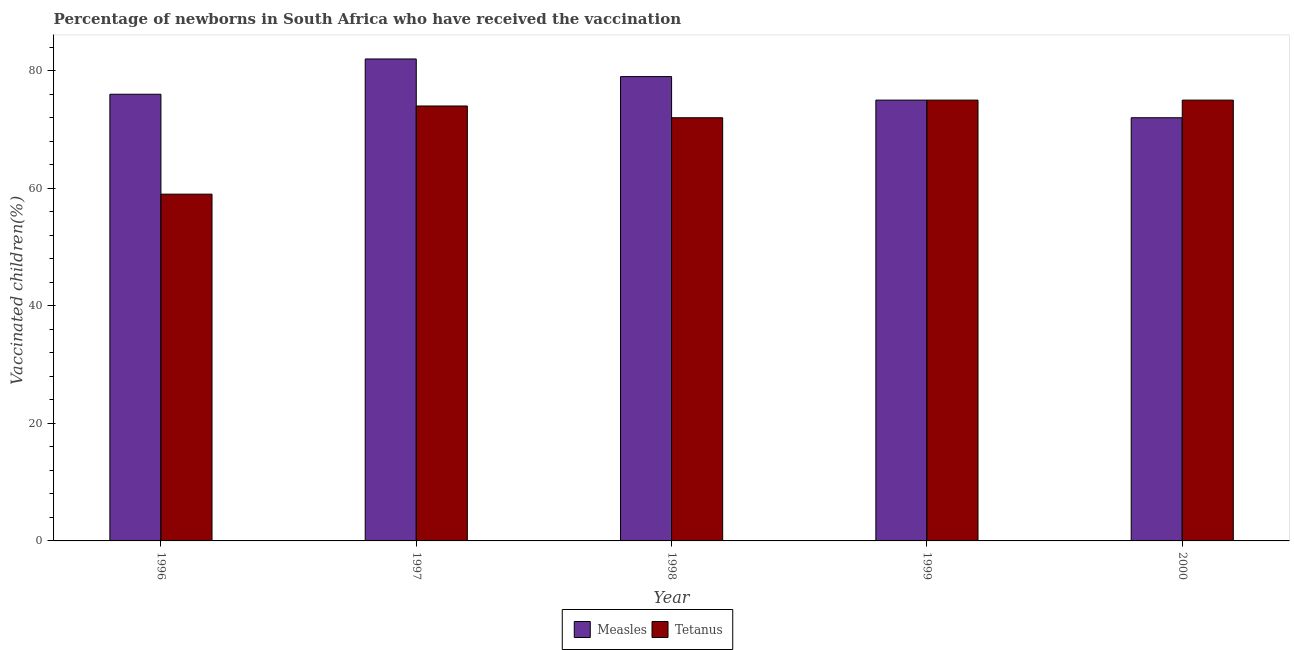How many groups of bars are there?
Provide a succinct answer. 5. Are the number of bars per tick equal to the number of legend labels?
Offer a terse response. Yes. How many bars are there on the 2nd tick from the left?
Ensure brevity in your answer.  2. How many bars are there on the 5th tick from the right?
Ensure brevity in your answer.  2. In how many cases, is the number of bars for a given year not equal to the number of legend labels?
Provide a succinct answer. 0. What is the percentage of newborns who received vaccination for measles in 2000?
Keep it short and to the point. 72. Across all years, what is the maximum percentage of newborns who received vaccination for tetanus?
Offer a very short reply. 75. Across all years, what is the minimum percentage of newborns who received vaccination for measles?
Your response must be concise. 72. What is the total percentage of newborns who received vaccination for tetanus in the graph?
Give a very brief answer. 355. What is the difference between the percentage of newborns who received vaccination for tetanus in 1996 and that in 2000?
Your answer should be compact. -16. What is the difference between the percentage of newborns who received vaccination for tetanus in 1998 and the percentage of newborns who received vaccination for measles in 2000?
Your response must be concise. -3. What is the ratio of the percentage of newborns who received vaccination for tetanus in 1996 to that in 2000?
Provide a short and direct response. 0.79. Is the percentage of newborns who received vaccination for measles in 1998 less than that in 2000?
Provide a succinct answer. No. What is the difference between the highest and the lowest percentage of newborns who received vaccination for tetanus?
Provide a succinct answer. 16. What does the 2nd bar from the left in 1998 represents?
Your answer should be very brief. Tetanus. What does the 1st bar from the right in 2000 represents?
Offer a terse response. Tetanus. How many bars are there?
Your answer should be very brief. 10. What is the difference between two consecutive major ticks on the Y-axis?
Make the answer very short. 20. Where does the legend appear in the graph?
Your response must be concise. Bottom center. What is the title of the graph?
Offer a very short reply. Percentage of newborns in South Africa who have received the vaccination. What is the label or title of the Y-axis?
Provide a short and direct response. Vaccinated children(%)
. What is the Vaccinated children(%)
 in Measles in 1996?
Your response must be concise. 76. What is the Vaccinated children(%)
 of Measles in 1998?
Make the answer very short. 79. What is the Vaccinated children(%)
 in Tetanus in 1998?
Your answer should be very brief. 72. What is the Vaccinated children(%)
 in Tetanus in 1999?
Give a very brief answer. 75. What is the Vaccinated children(%)
 in Tetanus in 2000?
Provide a succinct answer. 75. Across all years, what is the maximum Vaccinated children(%)
 of Measles?
Your answer should be very brief. 82. What is the total Vaccinated children(%)
 of Measles in the graph?
Your answer should be very brief. 384. What is the total Vaccinated children(%)
 of Tetanus in the graph?
Provide a short and direct response. 355. What is the difference between the Vaccinated children(%)
 of Measles in 1996 and that in 1997?
Your answer should be compact. -6. What is the difference between the Vaccinated children(%)
 of Measles in 1996 and that in 1998?
Provide a short and direct response. -3. What is the difference between the Vaccinated children(%)
 in Tetanus in 1996 and that in 2000?
Keep it short and to the point. -16. What is the difference between the Vaccinated children(%)
 of Measles in 1997 and that in 1998?
Your response must be concise. 3. What is the difference between the Vaccinated children(%)
 in Tetanus in 1997 and that in 1998?
Give a very brief answer. 2. What is the difference between the Vaccinated children(%)
 of Tetanus in 1997 and that in 1999?
Your answer should be very brief. -1. What is the difference between the Vaccinated children(%)
 in Tetanus in 1997 and that in 2000?
Offer a terse response. -1. What is the difference between the Vaccinated children(%)
 in Measles in 1998 and that in 1999?
Your response must be concise. 4. What is the difference between the Vaccinated children(%)
 of Tetanus in 1998 and that in 1999?
Offer a terse response. -3. What is the difference between the Vaccinated children(%)
 in Measles in 1997 and the Vaccinated children(%)
 in Tetanus in 1998?
Your answer should be very brief. 10. What is the difference between the Vaccinated children(%)
 in Measles in 1998 and the Vaccinated children(%)
 in Tetanus in 1999?
Ensure brevity in your answer.  4. What is the difference between the Vaccinated children(%)
 of Measles in 1998 and the Vaccinated children(%)
 of Tetanus in 2000?
Provide a succinct answer. 4. What is the average Vaccinated children(%)
 in Measles per year?
Keep it short and to the point. 76.8. What is the average Vaccinated children(%)
 in Tetanus per year?
Give a very brief answer. 71. In the year 1999, what is the difference between the Vaccinated children(%)
 of Measles and Vaccinated children(%)
 of Tetanus?
Your response must be concise. 0. What is the ratio of the Vaccinated children(%)
 of Measles in 1996 to that in 1997?
Your answer should be compact. 0.93. What is the ratio of the Vaccinated children(%)
 of Tetanus in 1996 to that in 1997?
Your answer should be very brief. 0.8. What is the ratio of the Vaccinated children(%)
 in Tetanus in 1996 to that in 1998?
Ensure brevity in your answer.  0.82. What is the ratio of the Vaccinated children(%)
 in Measles in 1996 to that in 1999?
Your response must be concise. 1.01. What is the ratio of the Vaccinated children(%)
 of Tetanus in 1996 to that in 1999?
Your answer should be very brief. 0.79. What is the ratio of the Vaccinated children(%)
 in Measles in 1996 to that in 2000?
Your answer should be compact. 1.06. What is the ratio of the Vaccinated children(%)
 of Tetanus in 1996 to that in 2000?
Provide a short and direct response. 0.79. What is the ratio of the Vaccinated children(%)
 in Measles in 1997 to that in 1998?
Your response must be concise. 1.04. What is the ratio of the Vaccinated children(%)
 of Tetanus in 1997 to that in 1998?
Ensure brevity in your answer.  1.03. What is the ratio of the Vaccinated children(%)
 in Measles in 1997 to that in 1999?
Your answer should be very brief. 1.09. What is the ratio of the Vaccinated children(%)
 of Tetanus in 1997 to that in 1999?
Ensure brevity in your answer.  0.99. What is the ratio of the Vaccinated children(%)
 of Measles in 1997 to that in 2000?
Provide a short and direct response. 1.14. What is the ratio of the Vaccinated children(%)
 of Tetanus in 1997 to that in 2000?
Your answer should be very brief. 0.99. What is the ratio of the Vaccinated children(%)
 in Measles in 1998 to that in 1999?
Provide a succinct answer. 1.05. What is the ratio of the Vaccinated children(%)
 in Tetanus in 1998 to that in 1999?
Your answer should be very brief. 0.96. What is the ratio of the Vaccinated children(%)
 in Measles in 1998 to that in 2000?
Provide a short and direct response. 1.1. What is the ratio of the Vaccinated children(%)
 in Measles in 1999 to that in 2000?
Offer a very short reply. 1.04. What is the difference between the highest and the second highest Vaccinated children(%)
 of Measles?
Keep it short and to the point. 3. What is the difference between the highest and the lowest Vaccinated children(%)
 of Measles?
Offer a very short reply. 10. 